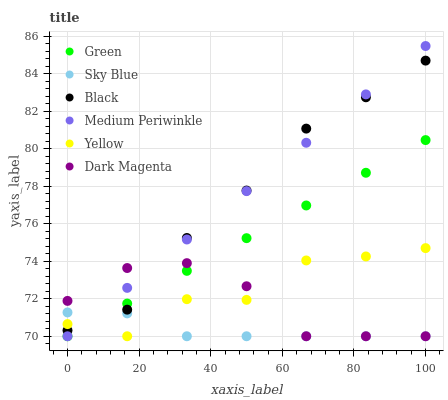Does Sky Blue have the minimum area under the curve?
Answer yes or no. Yes. Does Medium Periwinkle have the maximum area under the curve?
Answer yes or no. Yes. Does Yellow have the minimum area under the curve?
Answer yes or no. No. Does Yellow have the maximum area under the curve?
Answer yes or no. No. Is Medium Periwinkle the smoothest?
Answer yes or no. Yes. Is Yellow the roughest?
Answer yes or no. Yes. Is Yellow the smoothest?
Answer yes or no. No. Is Medium Periwinkle the roughest?
Answer yes or no. No. Does Dark Magenta have the lowest value?
Answer yes or no. Yes. Does Black have the lowest value?
Answer yes or no. No. Does Medium Periwinkle have the highest value?
Answer yes or no. Yes. Does Yellow have the highest value?
Answer yes or no. No. Does Yellow intersect Green?
Answer yes or no. Yes. Is Yellow less than Green?
Answer yes or no. No. Is Yellow greater than Green?
Answer yes or no. No. 